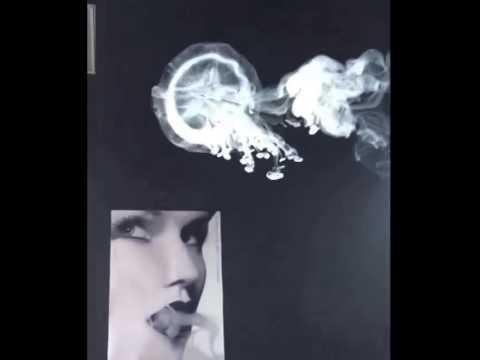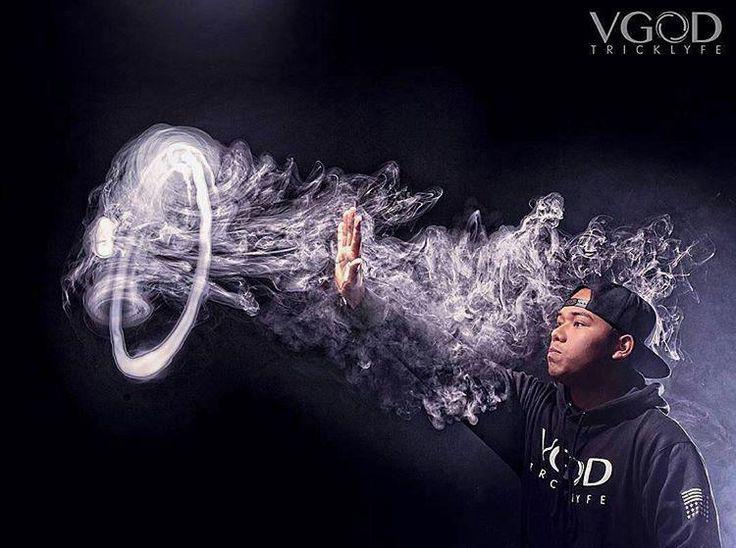The first image is the image on the left, the second image is the image on the right. Assess this claim about the two images: "There are exactly two smoke rings.". Correct or not? Answer yes or no. Yes. The first image is the image on the left, the second image is the image on the right. For the images shown, is this caption "The left and right image contains the same number of jelly fish looking smoke rings." true? Answer yes or no. Yes. 